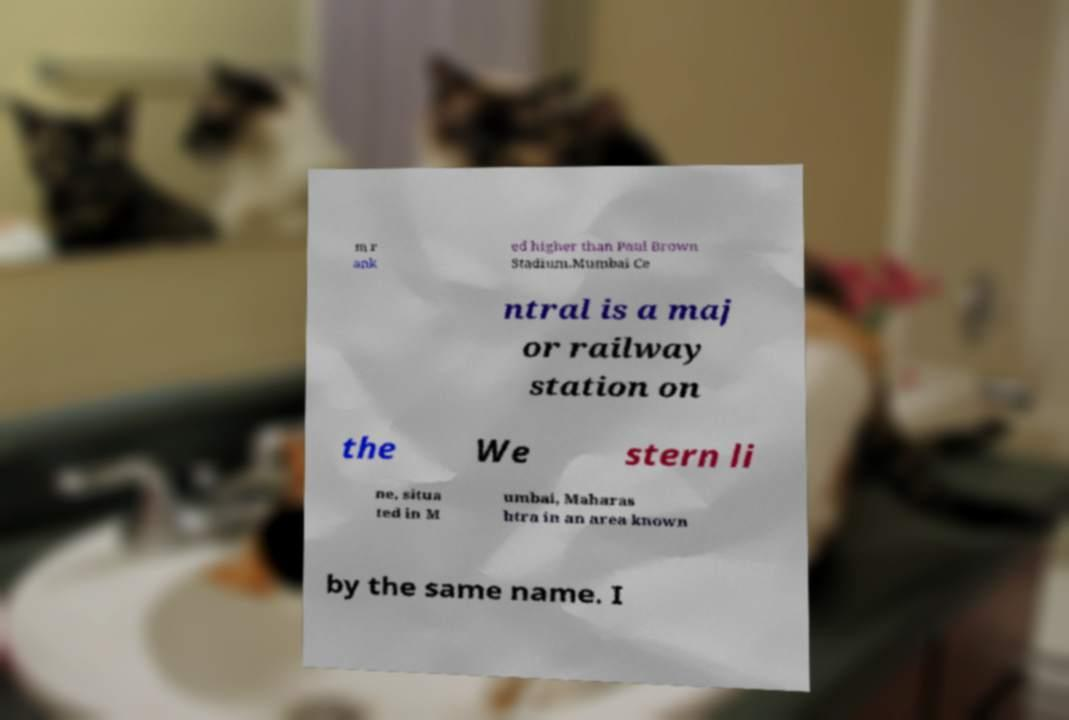I need the written content from this picture converted into text. Can you do that? m r ank ed higher than Paul Brown Stadium.Mumbai Ce ntral is a maj or railway station on the We stern li ne, situa ted in M umbai, Maharas htra in an area known by the same name. I 